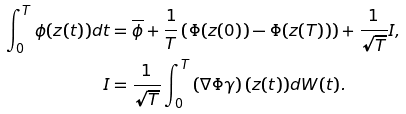<formula> <loc_0><loc_0><loc_500><loc_500>\int _ { 0 } ^ { T } \phi ( z ( t ) ) d t & = { \overline { \phi } } + \frac { 1 } { T } \left ( \Phi ( z ( 0 ) ) - \Phi ( z ( T ) ) \right ) + \frac { 1 } { \sqrt { T } } I , \\ I & = \frac { 1 } { \sqrt { T } } \int _ { 0 } ^ { T } \left ( \nabla \Phi \gamma \right ) ( z ( t ) ) d W ( t ) .</formula> 